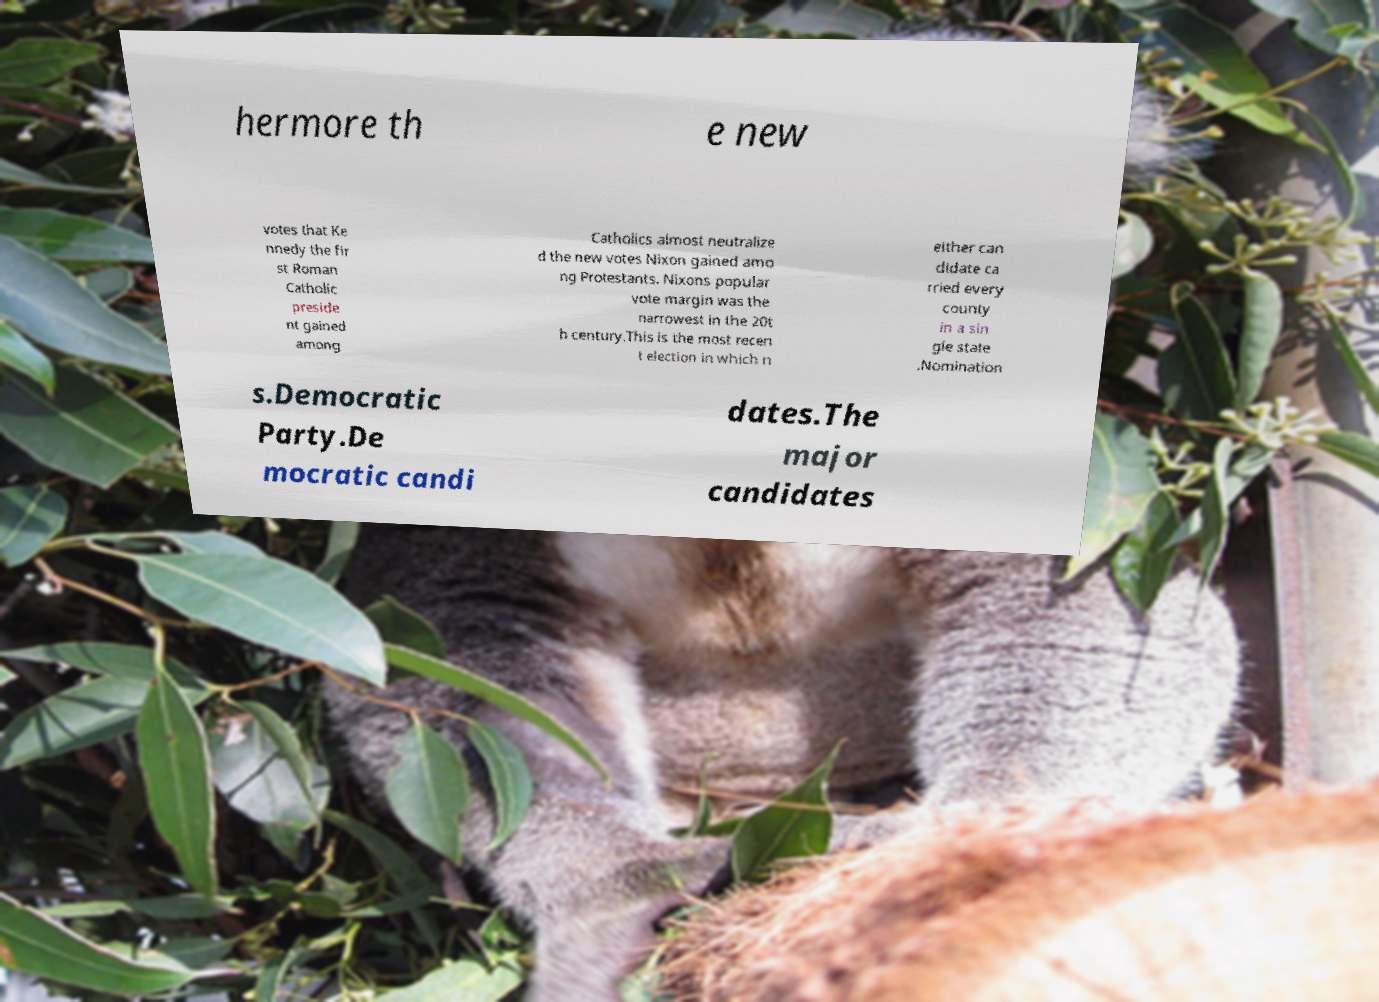Please read and relay the text visible in this image. What does it say? hermore th e new votes that Ke nnedy the fir st Roman Catholic preside nt gained among Catholics almost neutralize d the new votes Nixon gained amo ng Protestants. Nixons popular vote margin was the narrowest in the 20t h century.This is the most recen t election in which n either can didate ca rried every county in a sin gle state .Nomination s.Democratic Party.De mocratic candi dates.The major candidates 